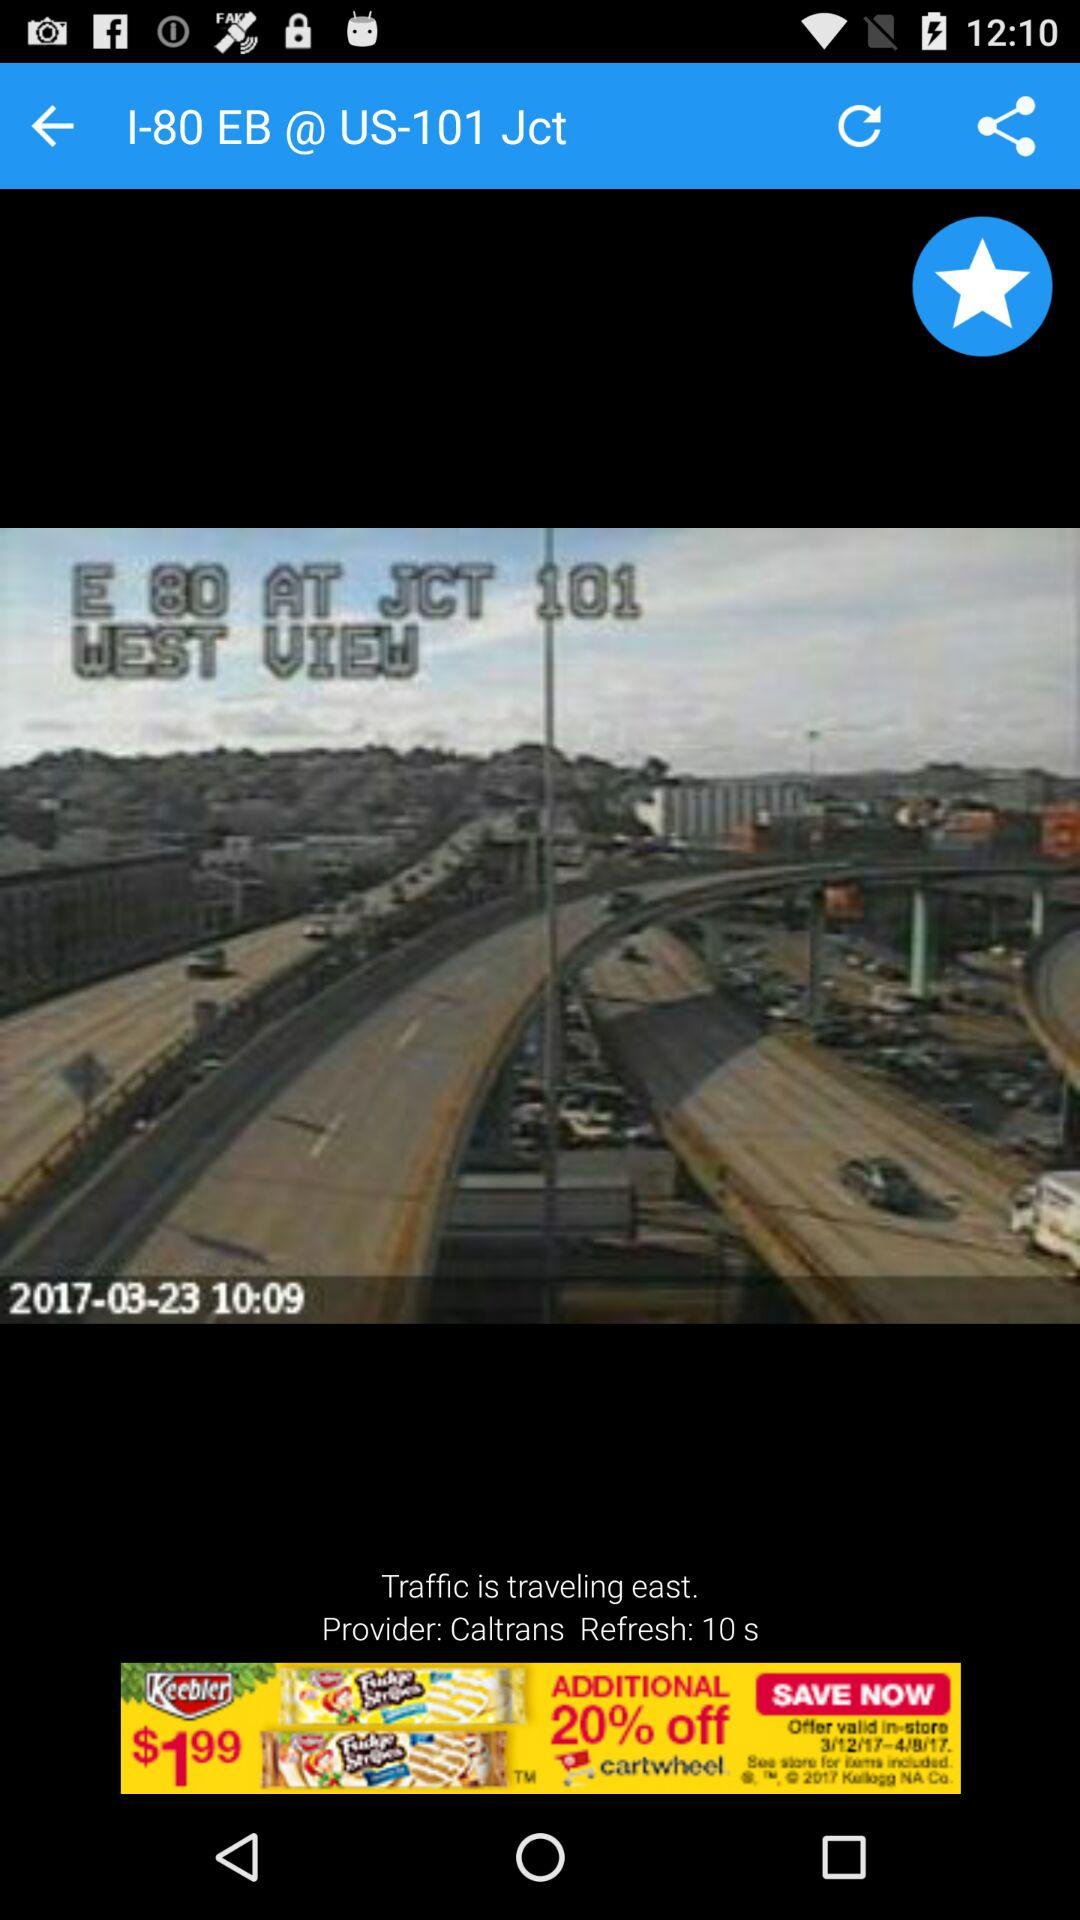How many more seconds until the next refresh?
Answer the question using a single word or phrase. 10 